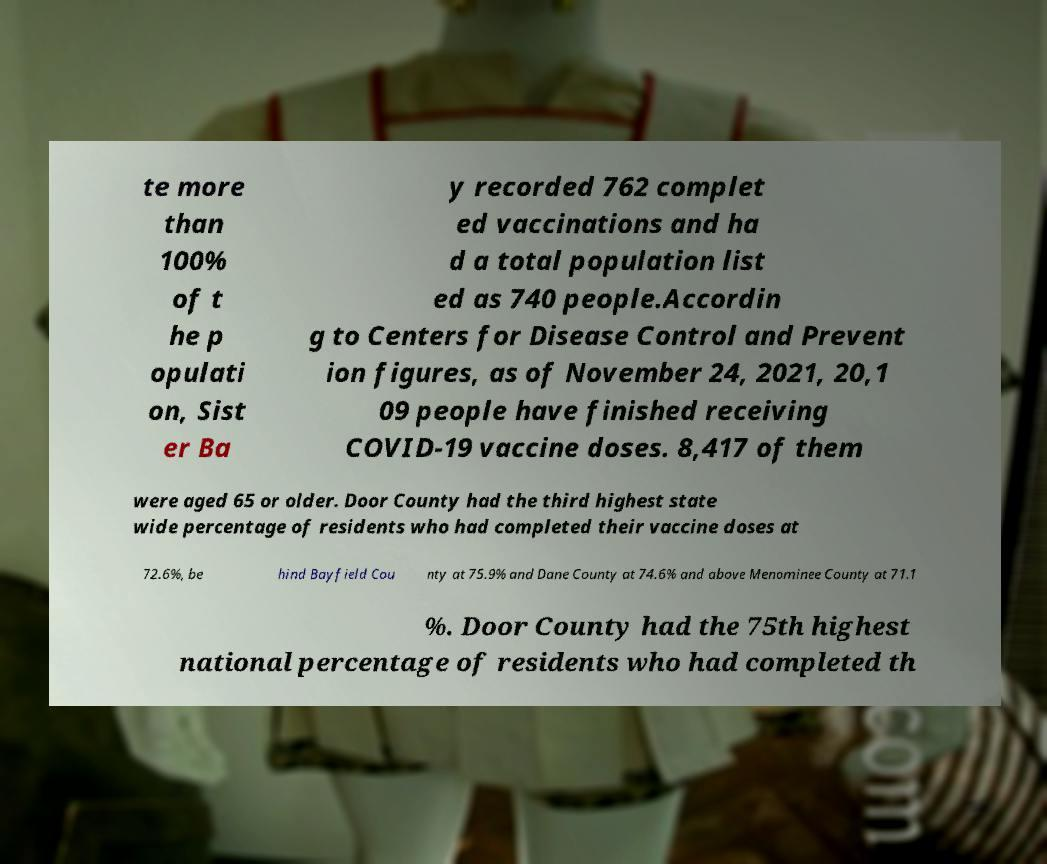Please read and relay the text visible in this image. What does it say? te more than 100% of t he p opulati on, Sist er Ba y recorded 762 complet ed vaccinations and ha d a total population list ed as 740 people.Accordin g to Centers for Disease Control and Prevent ion figures, as of November 24, 2021, 20,1 09 people have finished receiving COVID-19 vaccine doses. 8,417 of them were aged 65 or older. Door County had the third highest state wide percentage of residents who had completed their vaccine doses at 72.6%, be hind Bayfield Cou nty at 75.9% and Dane County at 74.6% and above Menominee County at 71.1 %. Door County had the 75th highest national percentage of residents who had completed th 